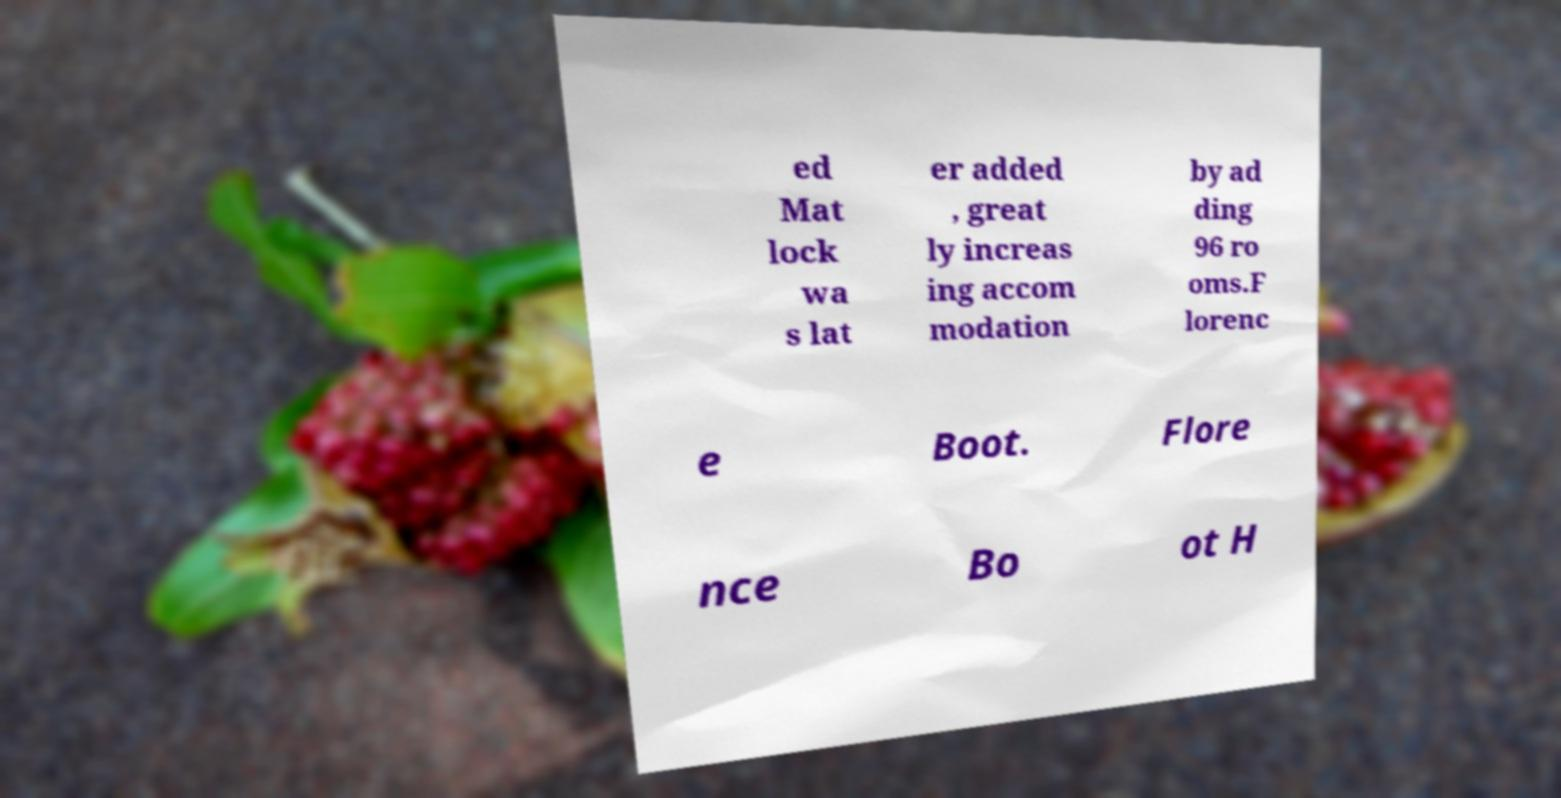Can you accurately transcribe the text from the provided image for me? ed Mat lock wa s lat er added , great ly increas ing accom modation by ad ding 96 ro oms.F lorenc e Boot. Flore nce Bo ot H 